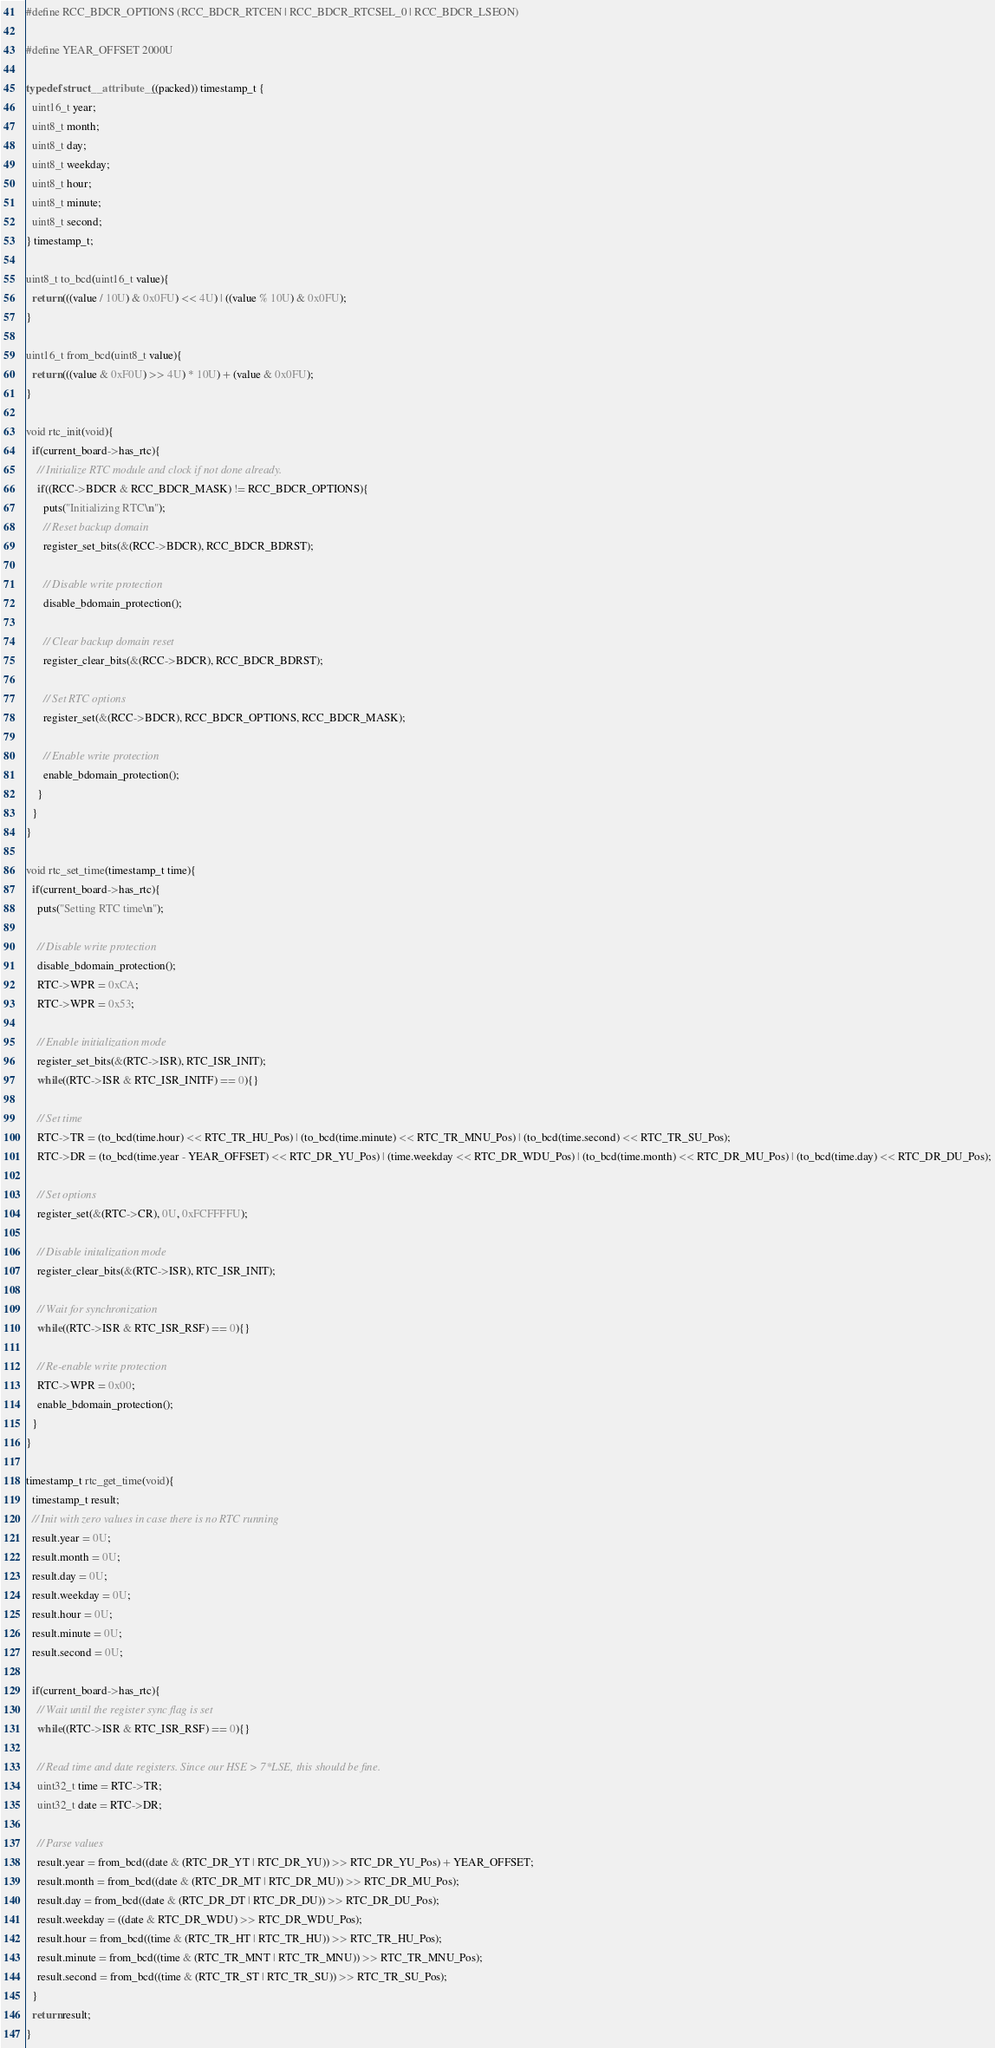Convert code to text. <code><loc_0><loc_0><loc_500><loc_500><_C_>#define RCC_BDCR_OPTIONS (RCC_BDCR_RTCEN | RCC_BDCR_RTCSEL_0 | RCC_BDCR_LSEON)

#define YEAR_OFFSET 2000U

typedef struct __attribute__((packed)) timestamp_t {
  uint16_t year;
  uint8_t month;
  uint8_t day;
  uint8_t weekday;
  uint8_t hour;
  uint8_t minute;
  uint8_t second;
} timestamp_t;

uint8_t to_bcd(uint16_t value){
  return (((value / 10U) & 0x0FU) << 4U) | ((value % 10U) & 0x0FU);
}

uint16_t from_bcd(uint8_t value){
  return (((value & 0xF0U) >> 4U) * 10U) + (value & 0x0FU);
}

void rtc_init(void){
  if(current_board->has_rtc){
    // Initialize RTC module and clock if not done already.
    if((RCC->BDCR & RCC_BDCR_MASK) != RCC_BDCR_OPTIONS){
      puts("Initializing RTC\n");
      // Reset backup domain
      register_set_bits(&(RCC->BDCR), RCC_BDCR_BDRST);

      // Disable write protection
      disable_bdomain_protection();

      // Clear backup domain reset
      register_clear_bits(&(RCC->BDCR), RCC_BDCR_BDRST);

      // Set RTC options
      register_set(&(RCC->BDCR), RCC_BDCR_OPTIONS, RCC_BDCR_MASK);

      // Enable write protection
      enable_bdomain_protection();
    }
  }
}

void rtc_set_time(timestamp_t time){
  if(current_board->has_rtc){
    puts("Setting RTC time\n");

    // Disable write protection
    disable_bdomain_protection();
    RTC->WPR = 0xCA;
    RTC->WPR = 0x53;

    // Enable initialization mode
    register_set_bits(&(RTC->ISR), RTC_ISR_INIT);
    while((RTC->ISR & RTC_ISR_INITF) == 0){}

    // Set time
    RTC->TR = (to_bcd(time.hour) << RTC_TR_HU_Pos) | (to_bcd(time.minute) << RTC_TR_MNU_Pos) | (to_bcd(time.second) << RTC_TR_SU_Pos);
    RTC->DR = (to_bcd(time.year - YEAR_OFFSET) << RTC_DR_YU_Pos) | (time.weekday << RTC_DR_WDU_Pos) | (to_bcd(time.month) << RTC_DR_MU_Pos) | (to_bcd(time.day) << RTC_DR_DU_Pos);

    // Set options
    register_set(&(RTC->CR), 0U, 0xFCFFFFU);

    // Disable initalization mode
    register_clear_bits(&(RTC->ISR), RTC_ISR_INIT);

    // Wait for synchronization
    while((RTC->ISR & RTC_ISR_RSF) == 0){}

    // Re-enable write protection
    RTC->WPR = 0x00;
    enable_bdomain_protection();
  }
}

timestamp_t rtc_get_time(void){
  timestamp_t result;
  // Init with zero values in case there is no RTC running
  result.year = 0U;
  result.month = 0U;
  result.day = 0U;
  result.weekday = 0U;
  result.hour = 0U;
  result.minute = 0U;
  result.second = 0U;

  if(current_board->has_rtc){
    // Wait until the register sync flag is set
    while((RTC->ISR & RTC_ISR_RSF) == 0){}

    // Read time and date registers. Since our HSE > 7*LSE, this should be fine.
    uint32_t time = RTC->TR;
    uint32_t date = RTC->DR;

    // Parse values
    result.year = from_bcd((date & (RTC_DR_YT | RTC_DR_YU)) >> RTC_DR_YU_Pos) + YEAR_OFFSET;
    result.month = from_bcd((date & (RTC_DR_MT | RTC_DR_MU)) >> RTC_DR_MU_Pos);
    result.day = from_bcd((date & (RTC_DR_DT | RTC_DR_DU)) >> RTC_DR_DU_Pos);
    result.weekday = ((date & RTC_DR_WDU) >> RTC_DR_WDU_Pos);
    result.hour = from_bcd((time & (RTC_TR_HT | RTC_TR_HU)) >> RTC_TR_HU_Pos);
    result.minute = from_bcd((time & (RTC_TR_MNT | RTC_TR_MNU)) >> RTC_TR_MNU_Pos);
    result.second = from_bcd((time & (RTC_TR_ST | RTC_TR_SU)) >> RTC_TR_SU_Pos);
  }
  return result;
}
</code> 